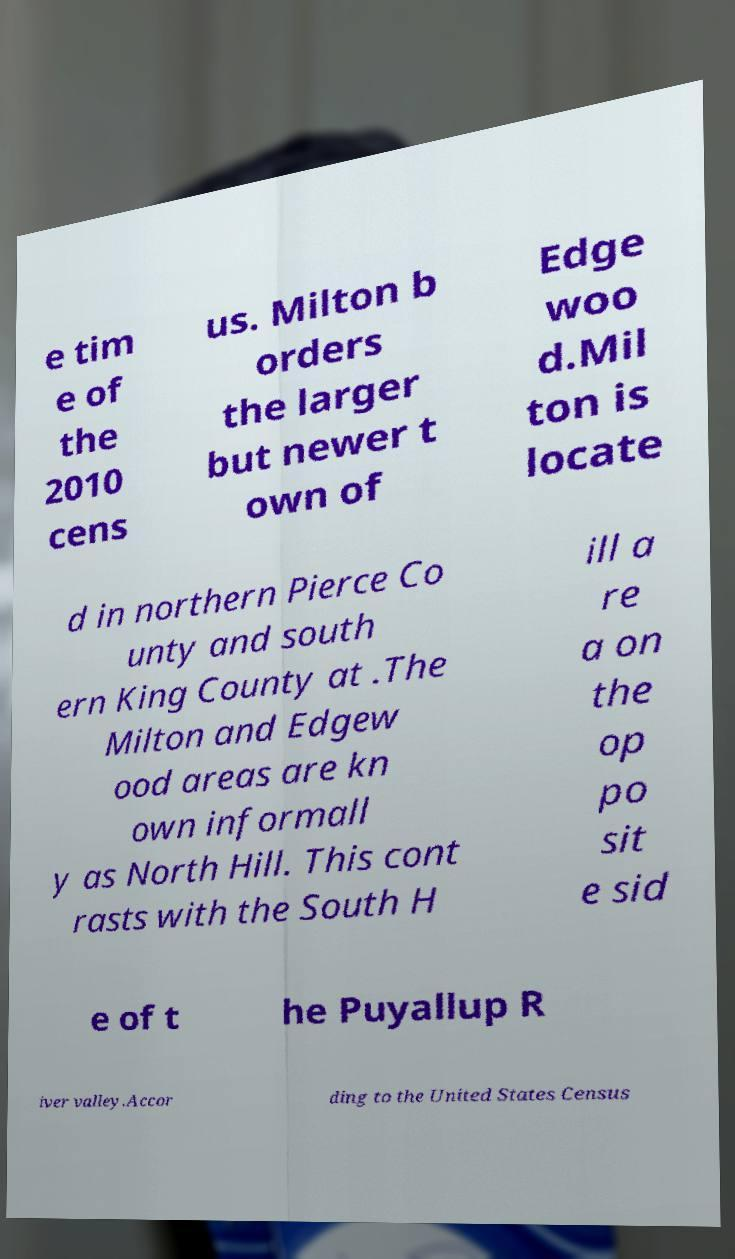Please read and relay the text visible in this image. What does it say? e tim e of the 2010 cens us. Milton b orders the larger but newer t own of Edge woo d.Mil ton is locate d in northern Pierce Co unty and south ern King County at .The Milton and Edgew ood areas are kn own informall y as North Hill. This cont rasts with the South H ill a re a on the op po sit e sid e of t he Puyallup R iver valley.Accor ding to the United States Census 